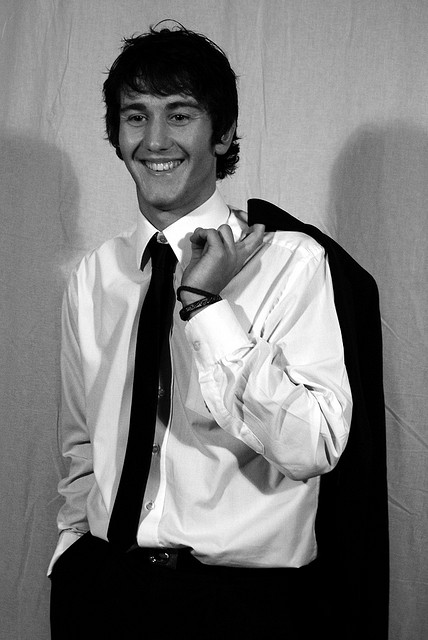<image>What catalog is this man posing for? I don't know what catalog this man is posing for. It could be 'sears', 'gq' or 'yearbook'. What catalog is this man posing for? I am not sure what catalog this man is posing for. It can be Sears, GQ, or a yearbook. 